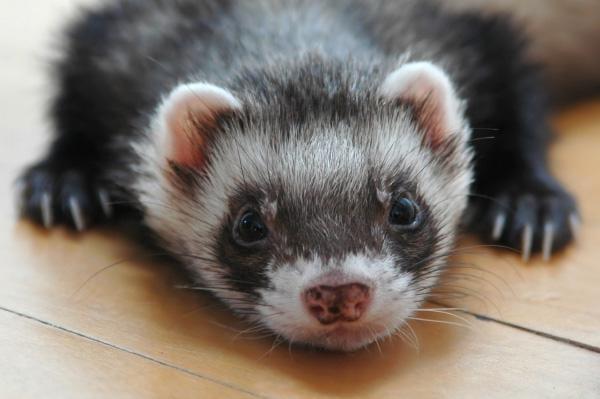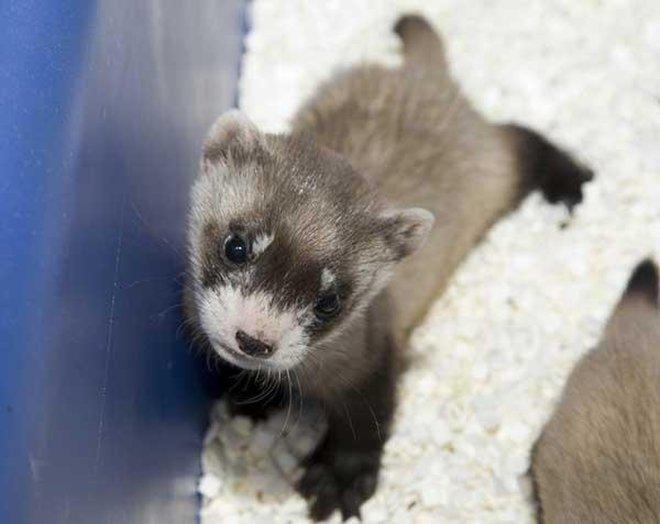The first image is the image on the left, the second image is the image on the right. Analyze the images presented: Is the assertion "There are exactly two ferrets outdoors." valid? Answer yes or no. No. The first image is the image on the left, the second image is the image on the right. Examine the images to the left and right. Is the description "Every image in the set contains a single ferret, in an outdoor setting." accurate? Answer yes or no. No. 